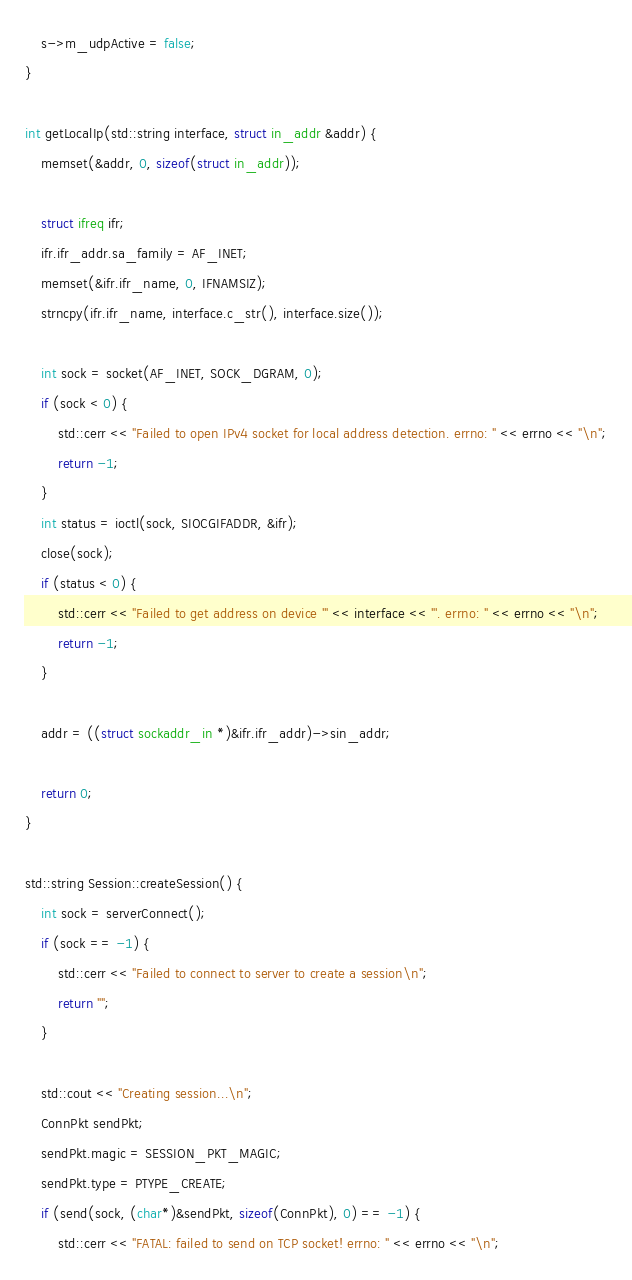Convert code to text. <code><loc_0><loc_0><loc_500><loc_500><_C++_>    s->m_udpActive = false;
}

int getLocalIp(std::string interface, struct in_addr &addr) {
    memset(&addr, 0, sizeof(struct in_addr));

    struct ifreq ifr;
    ifr.ifr_addr.sa_family = AF_INET;
    memset(&ifr.ifr_name, 0, IFNAMSIZ);
    strncpy(ifr.ifr_name, interface.c_str(), interface.size());

    int sock = socket(AF_INET, SOCK_DGRAM, 0);
    if (sock < 0) {
        std::cerr << "Failed to open IPv4 socket for local address detection. errno: " << errno << "\n";
        return -1;
    }
    int status = ioctl(sock, SIOCGIFADDR, &ifr);
    close(sock);
    if (status < 0) {
        std::cerr << "Failed to get address on device '" << interface << "'. errno: " << errno << "\n";
        return -1;
    }

    addr = ((struct sockaddr_in *)&ifr.ifr_addr)->sin_addr;

    return 0;
}

std::string Session::createSession() {
    int sock = serverConnect();
    if (sock == -1) {
        std::cerr << "Failed to connect to server to create a session\n";
        return "";
    }

    std::cout << "Creating session...\n";
    ConnPkt sendPkt;
    sendPkt.magic = SESSION_PKT_MAGIC;
    sendPkt.type = PTYPE_CREATE;
    if (send(sock, (char*)&sendPkt, sizeof(ConnPkt), 0) == -1) {
        std::cerr << "FATAL: failed to send on TCP socket! errno: " << errno << "\n";</code> 